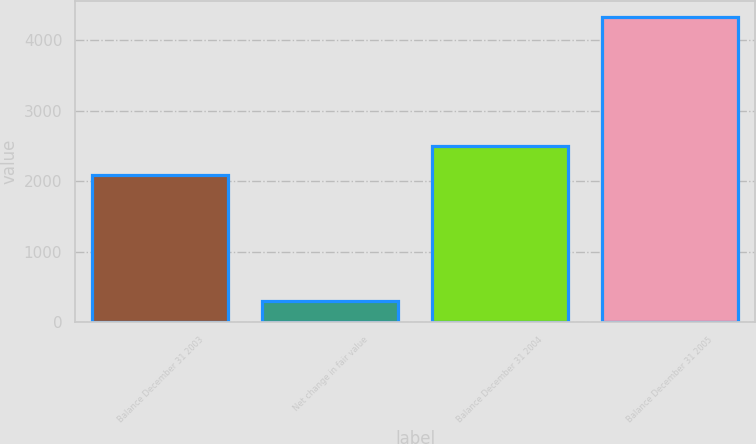Convert chart to OTSL. <chart><loc_0><loc_0><loc_500><loc_500><bar_chart><fcel>Balance December 31 2003<fcel>Net change in fair value<fcel>Balance December 31 2004<fcel>Balance December 31 2005<nl><fcel>2094<fcel>294<fcel>2498.4<fcel>4338<nl></chart> 